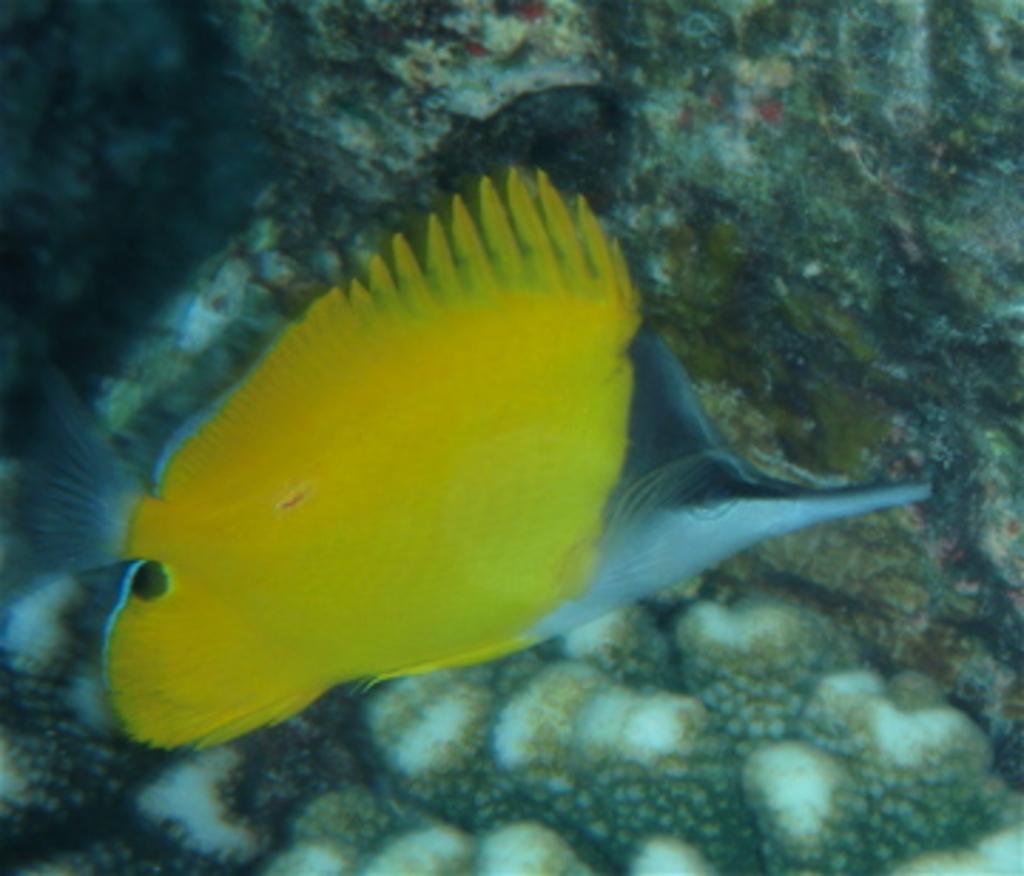Could you give a brief overview of what you see in this image? In this image I can see a fish which is in yellow and ash color. Back I can see a different background. 